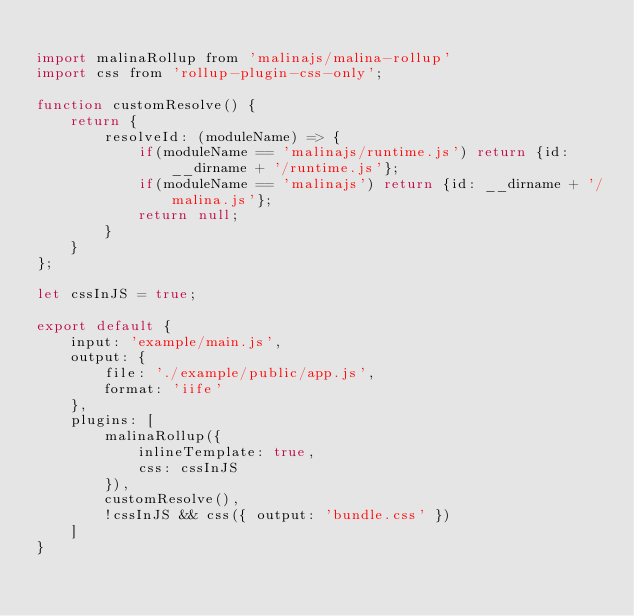<code> <loc_0><loc_0><loc_500><loc_500><_JavaScript_>
import malinaRollup from 'malinajs/malina-rollup'
import css from 'rollup-plugin-css-only';

function customResolve() {
    return {
        resolveId: (moduleName) => {
            if(moduleName == 'malinajs/runtime.js') return {id: __dirname + '/runtime.js'};
            if(moduleName == 'malinajs') return {id: __dirname + '/malina.js'};
            return null;
        }
    }
};

let cssInJS = true;

export default {
    input: 'example/main.js',
    output: {
        file: './example/public/app.js',
        format: 'iife'
    },
    plugins: [
        malinaRollup({
            inlineTemplate: true,
            css: cssInJS
        }),
        customResolve(),
        !cssInJS && css({ output: 'bundle.css' })
    ]
}
</code> 